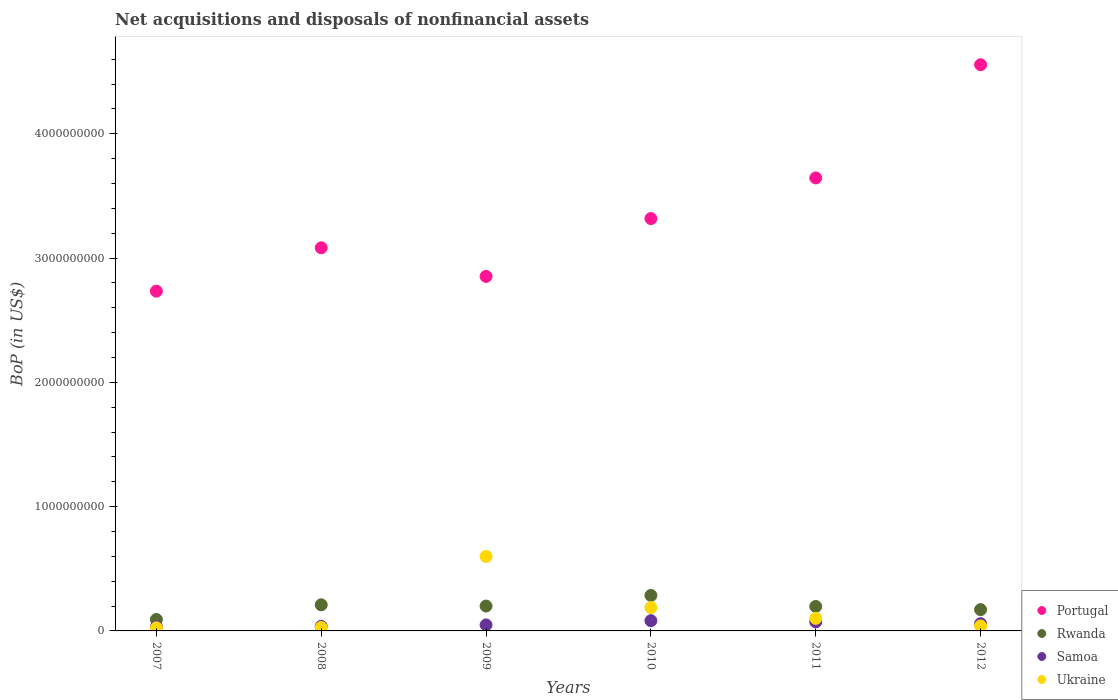What is the Balance of Payments in Portugal in 2008?
Give a very brief answer. 3.08e+09. Across all years, what is the maximum Balance of Payments in Samoa?
Ensure brevity in your answer.  8.24e+07. Across all years, what is the minimum Balance of Payments in Rwanda?
Keep it short and to the point. 9.20e+07. In which year was the Balance of Payments in Samoa maximum?
Your answer should be compact. 2010. What is the total Balance of Payments in Ukraine in the graph?
Provide a succinct answer. 9.81e+08. What is the difference between the Balance of Payments in Samoa in 2007 and that in 2012?
Offer a very short reply. -2.51e+07. What is the difference between the Balance of Payments in Rwanda in 2011 and the Balance of Payments in Ukraine in 2010?
Offer a terse response. 8.66e+06. What is the average Balance of Payments in Ukraine per year?
Ensure brevity in your answer.  1.64e+08. In the year 2007, what is the difference between the Balance of Payments in Rwanda and Balance of Payments in Portugal?
Your answer should be compact. -2.64e+09. In how many years, is the Balance of Payments in Samoa greater than 3200000000 US$?
Offer a very short reply. 0. What is the ratio of the Balance of Payments in Rwanda in 2007 to that in 2009?
Give a very brief answer. 0.46. Is the difference between the Balance of Payments in Rwanda in 2009 and 2010 greater than the difference between the Balance of Payments in Portugal in 2009 and 2010?
Make the answer very short. Yes. What is the difference between the highest and the second highest Balance of Payments in Ukraine?
Ensure brevity in your answer.  4.11e+08. What is the difference between the highest and the lowest Balance of Payments in Rwanda?
Make the answer very short. 1.94e+08. In how many years, is the Balance of Payments in Ukraine greater than the average Balance of Payments in Ukraine taken over all years?
Your answer should be compact. 2. Does the Balance of Payments in Ukraine monotonically increase over the years?
Offer a terse response. No. How many years are there in the graph?
Your answer should be compact. 6. Does the graph contain any zero values?
Offer a very short reply. No. How are the legend labels stacked?
Ensure brevity in your answer.  Vertical. What is the title of the graph?
Your response must be concise. Net acquisitions and disposals of nonfinancial assets. Does "Ghana" appear as one of the legend labels in the graph?
Offer a very short reply. No. What is the label or title of the X-axis?
Your response must be concise. Years. What is the label or title of the Y-axis?
Your answer should be compact. BoP (in US$). What is the BoP (in US$) in Portugal in 2007?
Offer a terse response. 2.73e+09. What is the BoP (in US$) of Rwanda in 2007?
Make the answer very short. 9.20e+07. What is the BoP (in US$) of Samoa in 2007?
Provide a short and direct response. 3.34e+07. What is the BoP (in US$) of Ukraine in 2007?
Provide a short and direct response. 2.50e+07. What is the BoP (in US$) in Portugal in 2008?
Your response must be concise. 3.08e+09. What is the BoP (in US$) of Rwanda in 2008?
Offer a terse response. 2.10e+08. What is the BoP (in US$) of Samoa in 2008?
Your answer should be very brief. 3.72e+07. What is the BoP (in US$) of Ukraine in 2008?
Provide a succinct answer. 2.80e+07. What is the BoP (in US$) of Portugal in 2009?
Give a very brief answer. 2.85e+09. What is the BoP (in US$) in Samoa in 2009?
Make the answer very short. 4.83e+07. What is the BoP (in US$) of Ukraine in 2009?
Offer a very short reply. 5.99e+08. What is the BoP (in US$) of Portugal in 2010?
Offer a terse response. 3.32e+09. What is the BoP (in US$) of Rwanda in 2010?
Make the answer very short. 2.86e+08. What is the BoP (in US$) in Samoa in 2010?
Your answer should be very brief. 8.24e+07. What is the BoP (in US$) of Ukraine in 2010?
Offer a terse response. 1.88e+08. What is the BoP (in US$) of Portugal in 2011?
Provide a short and direct response. 3.64e+09. What is the BoP (in US$) of Rwanda in 2011?
Make the answer very short. 1.97e+08. What is the BoP (in US$) of Samoa in 2011?
Offer a very short reply. 7.27e+07. What is the BoP (in US$) in Ukraine in 2011?
Ensure brevity in your answer.  1.01e+08. What is the BoP (in US$) of Portugal in 2012?
Your answer should be compact. 4.56e+09. What is the BoP (in US$) in Rwanda in 2012?
Give a very brief answer. 1.71e+08. What is the BoP (in US$) in Samoa in 2012?
Give a very brief answer. 5.84e+07. What is the BoP (in US$) of Ukraine in 2012?
Ensure brevity in your answer.  4.00e+07. Across all years, what is the maximum BoP (in US$) in Portugal?
Keep it short and to the point. 4.56e+09. Across all years, what is the maximum BoP (in US$) in Rwanda?
Ensure brevity in your answer.  2.86e+08. Across all years, what is the maximum BoP (in US$) in Samoa?
Your response must be concise. 8.24e+07. Across all years, what is the maximum BoP (in US$) in Ukraine?
Provide a short and direct response. 5.99e+08. Across all years, what is the minimum BoP (in US$) in Portugal?
Your answer should be very brief. 2.73e+09. Across all years, what is the minimum BoP (in US$) of Rwanda?
Keep it short and to the point. 9.20e+07. Across all years, what is the minimum BoP (in US$) in Samoa?
Give a very brief answer. 3.34e+07. Across all years, what is the minimum BoP (in US$) in Ukraine?
Your answer should be very brief. 2.50e+07. What is the total BoP (in US$) in Portugal in the graph?
Offer a terse response. 2.02e+1. What is the total BoP (in US$) of Rwanda in the graph?
Provide a short and direct response. 1.16e+09. What is the total BoP (in US$) of Samoa in the graph?
Your answer should be very brief. 3.32e+08. What is the total BoP (in US$) of Ukraine in the graph?
Give a very brief answer. 9.81e+08. What is the difference between the BoP (in US$) of Portugal in 2007 and that in 2008?
Make the answer very short. -3.49e+08. What is the difference between the BoP (in US$) of Rwanda in 2007 and that in 2008?
Your answer should be compact. -1.18e+08. What is the difference between the BoP (in US$) of Samoa in 2007 and that in 2008?
Make the answer very short. -3.81e+06. What is the difference between the BoP (in US$) in Portugal in 2007 and that in 2009?
Provide a succinct answer. -1.19e+08. What is the difference between the BoP (in US$) of Rwanda in 2007 and that in 2009?
Your response must be concise. -1.08e+08. What is the difference between the BoP (in US$) in Samoa in 2007 and that in 2009?
Give a very brief answer. -1.49e+07. What is the difference between the BoP (in US$) in Ukraine in 2007 and that in 2009?
Provide a short and direct response. -5.74e+08. What is the difference between the BoP (in US$) in Portugal in 2007 and that in 2010?
Your answer should be compact. -5.84e+08. What is the difference between the BoP (in US$) of Rwanda in 2007 and that in 2010?
Your response must be concise. -1.94e+08. What is the difference between the BoP (in US$) in Samoa in 2007 and that in 2010?
Offer a terse response. -4.90e+07. What is the difference between the BoP (in US$) of Ukraine in 2007 and that in 2010?
Provide a succinct answer. -1.63e+08. What is the difference between the BoP (in US$) in Portugal in 2007 and that in 2011?
Offer a very short reply. -9.11e+08. What is the difference between the BoP (in US$) in Rwanda in 2007 and that in 2011?
Provide a succinct answer. -1.05e+08. What is the difference between the BoP (in US$) of Samoa in 2007 and that in 2011?
Provide a succinct answer. -3.93e+07. What is the difference between the BoP (in US$) in Ukraine in 2007 and that in 2011?
Keep it short and to the point. -7.60e+07. What is the difference between the BoP (in US$) of Portugal in 2007 and that in 2012?
Offer a terse response. -1.82e+09. What is the difference between the BoP (in US$) of Rwanda in 2007 and that in 2012?
Offer a terse response. -7.92e+07. What is the difference between the BoP (in US$) of Samoa in 2007 and that in 2012?
Provide a short and direct response. -2.51e+07. What is the difference between the BoP (in US$) of Ukraine in 2007 and that in 2012?
Make the answer very short. -1.50e+07. What is the difference between the BoP (in US$) of Portugal in 2008 and that in 2009?
Keep it short and to the point. 2.30e+08. What is the difference between the BoP (in US$) in Rwanda in 2008 and that in 2009?
Your answer should be compact. 1.01e+07. What is the difference between the BoP (in US$) in Samoa in 2008 and that in 2009?
Keep it short and to the point. -1.11e+07. What is the difference between the BoP (in US$) of Ukraine in 2008 and that in 2009?
Ensure brevity in your answer.  -5.71e+08. What is the difference between the BoP (in US$) in Portugal in 2008 and that in 2010?
Provide a succinct answer. -2.35e+08. What is the difference between the BoP (in US$) in Rwanda in 2008 and that in 2010?
Keep it short and to the point. -7.56e+07. What is the difference between the BoP (in US$) of Samoa in 2008 and that in 2010?
Provide a short and direct response. -4.52e+07. What is the difference between the BoP (in US$) of Ukraine in 2008 and that in 2010?
Ensure brevity in your answer.  -1.60e+08. What is the difference between the BoP (in US$) of Portugal in 2008 and that in 2011?
Offer a terse response. -5.62e+08. What is the difference between the BoP (in US$) of Rwanda in 2008 and that in 2011?
Your answer should be compact. 1.34e+07. What is the difference between the BoP (in US$) in Samoa in 2008 and that in 2011?
Give a very brief answer. -3.55e+07. What is the difference between the BoP (in US$) in Ukraine in 2008 and that in 2011?
Provide a succinct answer. -7.30e+07. What is the difference between the BoP (in US$) of Portugal in 2008 and that in 2012?
Offer a terse response. -1.47e+09. What is the difference between the BoP (in US$) of Rwanda in 2008 and that in 2012?
Your answer should be compact. 3.88e+07. What is the difference between the BoP (in US$) of Samoa in 2008 and that in 2012?
Make the answer very short. -2.13e+07. What is the difference between the BoP (in US$) in Ukraine in 2008 and that in 2012?
Make the answer very short. -1.20e+07. What is the difference between the BoP (in US$) in Portugal in 2009 and that in 2010?
Your answer should be compact. -4.66e+08. What is the difference between the BoP (in US$) of Rwanda in 2009 and that in 2010?
Your response must be concise. -8.56e+07. What is the difference between the BoP (in US$) in Samoa in 2009 and that in 2010?
Provide a succinct answer. -3.41e+07. What is the difference between the BoP (in US$) of Ukraine in 2009 and that in 2010?
Keep it short and to the point. 4.11e+08. What is the difference between the BoP (in US$) in Portugal in 2009 and that in 2011?
Your answer should be very brief. -7.92e+08. What is the difference between the BoP (in US$) in Rwanda in 2009 and that in 2011?
Give a very brief answer. 3.34e+06. What is the difference between the BoP (in US$) in Samoa in 2009 and that in 2011?
Provide a short and direct response. -2.44e+07. What is the difference between the BoP (in US$) of Ukraine in 2009 and that in 2011?
Your response must be concise. 4.98e+08. What is the difference between the BoP (in US$) of Portugal in 2009 and that in 2012?
Provide a short and direct response. -1.70e+09. What is the difference between the BoP (in US$) of Rwanda in 2009 and that in 2012?
Provide a short and direct response. 2.88e+07. What is the difference between the BoP (in US$) of Samoa in 2009 and that in 2012?
Make the answer very short. -1.01e+07. What is the difference between the BoP (in US$) in Ukraine in 2009 and that in 2012?
Your answer should be very brief. 5.59e+08. What is the difference between the BoP (in US$) in Portugal in 2010 and that in 2011?
Keep it short and to the point. -3.27e+08. What is the difference between the BoP (in US$) in Rwanda in 2010 and that in 2011?
Ensure brevity in your answer.  8.90e+07. What is the difference between the BoP (in US$) in Samoa in 2010 and that in 2011?
Ensure brevity in your answer.  9.68e+06. What is the difference between the BoP (in US$) in Ukraine in 2010 and that in 2011?
Provide a short and direct response. 8.70e+07. What is the difference between the BoP (in US$) in Portugal in 2010 and that in 2012?
Make the answer very short. -1.24e+09. What is the difference between the BoP (in US$) in Rwanda in 2010 and that in 2012?
Provide a short and direct response. 1.14e+08. What is the difference between the BoP (in US$) of Samoa in 2010 and that in 2012?
Offer a terse response. 2.39e+07. What is the difference between the BoP (in US$) of Ukraine in 2010 and that in 2012?
Your answer should be very brief. 1.48e+08. What is the difference between the BoP (in US$) of Portugal in 2011 and that in 2012?
Your answer should be compact. -9.11e+08. What is the difference between the BoP (in US$) in Rwanda in 2011 and that in 2012?
Your answer should be compact. 2.54e+07. What is the difference between the BoP (in US$) of Samoa in 2011 and that in 2012?
Your answer should be compact. 1.42e+07. What is the difference between the BoP (in US$) of Ukraine in 2011 and that in 2012?
Make the answer very short. 6.10e+07. What is the difference between the BoP (in US$) of Portugal in 2007 and the BoP (in US$) of Rwanda in 2008?
Keep it short and to the point. 2.52e+09. What is the difference between the BoP (in US$) of Portugal in 2007 and the BoP (in US$) of Samoa in 2008?
Provide a short and direct response. 2.70e+09. What is the difference between the BoP (in US$) of Portugal in 2007 and the BoP (in US$) of Ukraine in 2008?
Give a very brief answer. 2.71e+09. What is the difference between the BoP (in US$) of Rwanda in 2007 and the BoP (in US$) of Samoa in 2008?
Make the answer very short. 5.48e+07. What is the difference between the BoP (in US$) in Rwanda in 2007 and the BoP (in US$) in Ukraine in 2008?
Ensure brevity in your answer.  6.40e+07. What is the difference between the BoP (in US$) of Samoa in 2007 and the BoP (in US$) of Ukraine in 2008?
Ensure brevity in your answer.  5.38e+06. What is the difference between the BoP (in US$) in Portugal in 2007 and the BoP (in US$) in Rwanda in 2009?
Provide a short and direct response. 2.53e+09. What is the difference between the BoP (in US$) in Portugal in 2007 and the BoP (in US$) in Samoa in 2009?
Make the answer very short. 2.69e+09. What is the difference between the BoP (in US$) in Portugal in 2007 and the BoP (in US$) in Ukraine in 2009?
Provide a short and direct response. 2.13e+09. What is the difference between the BoP (in US$) of Rwanda in 2007 and the BoP (in US$) of Samoa in 2009?
Give a very brief answer. 4.37e+07. What is the difference between the BoP (in US$) in Rwanda in 2007 and the BoP (in US$) in Ukraine in 2009?
Keep it short and to the point. -5.07e+08. What is the difference between the BoP (in US$) of Samoa in 2007 and the BoP (in US$) of Ukraine in 2009?
Offer a very short reply. -5.66e+08. What is the difference between the BoP (in US$) in Portugal in 2007 and the BoP (in US$) in Rwanda in 2010?
Make the answer very short. 2.45e+09. What is the difference between the BoP (in US$) in Portugal in 2007 and the BoP (in US$) in Samoa in 2010?
Make the answer very short. 2.65e+09. What is the difference between the BoP (in US$) in Portugal in 2007 and the BoP (in US$) in Ukraine in 2010?
Give a very brief answer. 2.55e+09. What is the difference between the BoP (in US$) in Rwanda in 2007 and the BoP (in US$) in Samoa in 2010?
Provide a succinct answer. 9.66e+06. What is the difference between the BoP (in US$) of Rwanda in 2007 and the BoP (in US$) of Ukraine in 2010?
Keep it short and to the point. -9.60e+07. What is the difference between the BoP (in US$) of Samoa in 2007 and the BoP (in US$) of Ukraine in 2010?
Ensure brevity in your answer.  -1.55e+08. What is the difference between the BoP (in US$) of Portugal in 2007 and the BoP (in US$) of Rwanda in 2011?
Your answer should be compact. 2.54e+09. What is the difference between the BoP (in US$) in Portugal in 2007 and the BoP (in US$) in Samoa in 2011?
Ensure brevity in your answer.  2.66e+09. What is the difference between the BoP (in US$) in Portugal in 2007 and the BoP (in US$) in Ukraine in 2011?
Offer a very short reply. 2.63e+09. What is the difference between the BoP (in US$) of Rwanda in 2007 and the BoP (in US$) of Samoa in 2011?
Provide a short and direct response. 1.93e+07. What is the difference between the BoP (in US$) of Rwanda in 2007 and the BoP (in US$) of Ukraine in 2011?
Keep it short and to the point. -8.96e+06. What is the difference between the BoP (in US$) of Samoa in 2007 and the BoP (in US$) of Ukraine in 2011?
Your response must be concise. -6.76e+07. What is the difference between the BoP (in US$) in Portugal in 2007 and the BoP (in US$) in Rwanda in 2012?
Your response must be concise. 2.56e+09. What is the difference between the BoP (in US$) of Portugal in 2007 and the BoP (in US$) of Samoa in 2012?
Offer a terse response. 2.68e+09. What is the difference between the BoP (in US$) of Portugal in 2007 and the BoP (in US$) of Ukraine in 2012?
Your response must be concise. 2.69e+09. What is the difference between the BoP (in US$) of Rwanda in 2007 and the BoP (in US$) of Samoa in 2012?
Provide a short and direct response. 3.36e+07. What is the difference between the BoP (in US$) in Rwanda in 2007 and the BoP (in US$) in Ukraine in 2012?
Offer a terse response. 5.20e+07. What is the difference between the BoP (in US$) in Samoa in 2007 and the BoP (in US$) in Ukraine in 2012?
Provide a succinct answer. -6.62e+06. What is the difference between the BoP (in US$) in Portugal in 2008 and the BoP (in US$) in Rwanda in 2009?
Your answer should be compact. 2.88e+09. What is the difference between the BoP (in US$) of Portugal in 2008 and the BoP (in US$) of Samoa in 2009?
Your answer should be very brief. 3.03e+09. What is the difference between the BoP (in US$) in Portugal in 2008 and the BoP (in US$) in Ukraine in 2009?
Your answer should be compact. 2.48e+09. What is the difference between the BoP (in US$) in Rwanda in 2008 and the BoP (in US$) in Samoa in 2009?
Make the answer very short. 1.62e+08. What is the difference between the BoP (in US$) in Rwanda in 2008 and the BoP (in US$) in Ukraine in 2009?
Your response must be concise. -3.89e+08. What is the difference between the BoP (in US$) in Samoa in 2008 and the BoP (in US$) in Ukraine in 2009?
Offer a very short reply. -5.62e+08. What is the difference between the BoP (in US$) of Portugal in 2008 and the BoP (in US$) of Rwanda in 2010?
Your answer should be very brief. 2.80e+09. What is the difference between the BoP (in US$) of Portugal in 2008 and the BoP (in US$) of Samoa in 2010?
Ensure brevity in your answer.  3.00e+09. What is the difference between the BoP (in US$) in Portugal in 2008 and the BoP (in US$) in Ukraine in 2010?
Ensure brevity in your answer.  2.89e+09. What is the difference between the BoP (in US$) in Rwanda in 2008 and the BoP (in US$) in Samoa in 2010?
Your answer should be compact. 1.28e+08. What is the difference between the BoP (in US$) in Rwanda in 2008 and the BoP (in US$) in Ukraine in 2010?
Your response must be concise. 2.21e+07. What is the difference between the BoP (in US$) in Samoa in 2008 and the BoP (in US$) in Ukraine in 2010?
Your answer should be very brief. -1.51e+08. What is the difference between the BoP (in US$) in Portugal in 2008 and the BoP (in US$) in Rwanda in 2011?
Provide a short and direct response. 2.89e+09. What is the difference between the BoP (in US$) of Portugal in 2008 and the BoP (in US$) of Samoa in 2011?
Give a very brief answer. 3.01e+09. What is the difference between the BoP (in US$) of Portugal in 2008 and the BoP (in US$) of Ukraine in 2011?
Your answer should be very brief. 2.98e+09. What is the difference between the BoP (in US$) of Rwanda in 2008 and the BoP (in US$) of Samoa in 2011?
Ensure brevity in your answer.  1.37e+08. What is the difference between the BoP (in US$) in Rwanda in 2008 and the BoP (in US$) in Ukraine in 2011?
Your response must be concise. 1.09e+08. What is the difference between the BoP (in US$) in Samoa in 2008 and the BoP (in US$) in Ukraine in 2011?
Provide a succinct answer. -6.38e+07. What is the difference between the BoP (in US$) in Portugal in 2008 and the BoP (in US$) in Rwanda in 2012?
Your answer should be very brief. 2.91e+09. What is the difference between the BoP (in US$) in Portugal in 2008 and the BoP (in US$) in Samoa in 2012?
Keep it short and to the point. 3.02e+09. What is the difference between the BoP (in US$) in Portugal in 2008 and the BoP (in US$) in Ukraine in 2012?
Your answer should be very brief. 3.04e+09. What is the difference between the BoP (in US$) of Rwanda in 2008 and the BoP (in US$) of Samoa in 2012?
Ensure brevity in your answer.  1.52e+08. What is the difference between the BoP (in US$) in Rwanda in 2008 and the BoP (in US$) in Ukraine in 2012?
Your answer should be very brief. 1.70e+08. What is the difference between the BoP (in US$) of Samoa in 2008 and the BoP (in US$) of Ukraine in 2012?
Make the answer very short. -2.81e+06. What is the difference between the BoP (in US$) in Portugal in 2009 and the BoP (in US$) in Rwanda in 2010?
Offer a very short reply. 2.57e+09. What is the difference between the BoP (in US$) in Portugal in 2009 and the BoP (in US$) in Samoa in 2010?
Keep it short and to the point. 2.77e+09. What is the difference between the BoP (in US$) in Portugal in 2009 and the BoP (in US$) in Ukraine in 2010?
Your answer should be compact. 2.66e+09. What is the difference between the BoP (in US$) of Rwanda in 2009 and the BoP (in US$) of Samoa in 2010?
Offer a very short reply. 1.18e+08. What is the difference between the BoP (in US$) of Rwanda in 2009 and the BoP (in US$) of Ukraine in 2010?
Your answer should be compact. 1.20e+07. What is the difference between the BoP (in US$) in Samoa in 2009 and the BoP (in US$) in Ukraine in 2010?
Offer a very short reply. -1.40e+08. What is the difference between the BoP (in US$) of Portugal in 2009 and the BoP (in US$) of Rwanda in 2011?
Ensure brevity in your answer.  2.66e+09. What is the difference between the BoP (in US$) in Portugal in 2009 and the BoP (in US$) in Samoa in 2011?
Provide a short and direct response. 2.78e+09. What is the difference between the BoP (in US$) in Portugal in 2009 and the BoP (in US$) in Ukraine in 2011?
Provide a succinct answer. 2.75e+09. What is the difference between the BoP (in US$) in Rwanda in 2009 and the BoP (in US$) in Samoa in 2011?
Make the answer very short. 1.27e+08. What is the difference between the BoP (in US$) of Rwanda in 2009 and the BoP (in US$) of Ukraine in 2011?
Offer a terse response. 9.90e+07. What is the difference between the BoP (in US$) of Samoa in 2009 and the BoP (in US$) of Ukraine in 2011?
Offer a very short reply. -5.27e+07. What is the difference between the BoP (in US$) in Portugal in 2009 and the BoP (in US$) in Rwanda in 2012?
Your answer should be compact. 2.68e+09. What is the difference between the BoP (in US$) of Portugal in 2009 and the BoP (in US$) of Samoa in 2012?
Provide a succinct answer. 2.79e+09. What is the difference between the BoP (in US$) in Portugal in 2009 and the BoP (in US$) in Ukraine in 2012?
Keep it short and to the point. 2.81e+09. What is the difference between the BoP (in US$) in Rwanda in 2009 and the BoP (in US$) in Samoa in 2012?
Your response must be concise. 1.42e+08. What is the difference between the BoP (in US$) in Rwanda in 2009 and the BoP (in US$) in Ukraine in 2012?
Ensure brevity in your answer.  1.60e+08. What is the difference between the BoP (in US$) in Samoa in 2009 and the BoP (in US$) in Ukraine in 2012?
Your answer should be very brief. 8.31e+06. What is the difference between the BoP (in US$) of Portugal in 2010 and the BoP (in US$) of Rwanda in 2011?
Offer a very short reply. 3.12e+09. What is the difference between the BoP (in US$) in Portugal in 2010 and the BoP (in US$) in Samoa in 2011?
Give a very brief answer. 3.25e+09. What is the difference between the BoP (in US$) in Portugal in 2010 and the BoP (in US$) in Ukraine in 2011?
Keep it short and to the point. 3.22e+09. What is the difference between the BoP (in US$) in Rwanda in 2010 and the BoP (in US$) in Samoa in 2011?
Provide a succinct answer. 2.13e+08. What is the difference between the BoP (in US$) in Rwanda in 2010 and the BoP (in US$) in Ukraine in 2011?
Keep it short and to the point. 1.85e+08. What is the difference between the BoP (in US$) of Samoa in 2010 and the BoP (in US$) of Ukraine in 2011?
Offer a very short reply. -1.86e+07. What is the difference between the BoP (in US$) in Portugal in 2010 and the BoP (in US$) in Rwanda in 2012?
Your answer should be very brief. 3.15e+09. What is the difference between the BoP (in US$) in Portugal in 2010 and the BoP (in US$) in Samoa in 2012?
Offer a very short reply. 3.26e+09. What is the difference between the BoP (in US$) of Portugal in 2010 and the BoP (in US$) of Ukraine in 2012?
Give a very brief answer. 3.28e+09. What is the difference between the BoP (in US$) of Rwanda in 2010 and the BoP (in US$) of Samoa in 2012?
Offer a terse response. 2.27e+08. What is the difference between the BoP (in US$) of Rwanda in 2010 and the BoP (in US$) of Ukraine in 2012?
Make the answer very short. 2.46e+08. What is the difference between the BoP (in US$) of Samoa in 2010 and the BoP (in US$) of Ukraine in 2012?
Your response must be concise. 4.24e+07. What is the difference between the BoP (in US$) of Portugal in 2011 and the BoP (in US$) of Rwanda in 2012?
Make the answer very short. 3.47e+09. What is the difference between the BoP (in US$) of Portugal in 2011 and the BoP (in US$) of Samoa in 2012?
Keep it short and to the point. 3.59e+09. What is the difference between the BoP (in US$) in Portugal in 2011 and the BoP (in US$) in Ukraine in 2012?
Give a very brief answer. 3.60e+09. What is the difference between the BoP (in US$) in Rwanda in 2011 and the BoP (in US$) in Samoa in 2012?
Ensure brevity in your answer.  1.38e+08. What is the difference between the BoP (in US$) in Rwanda in 2011 and the BoP (in US$) in Ukraine in 2012?
Provide a short and direct response. 1.57e+08. What is the difference between the BoP (in US$) of Samoa in 2011 and the BoP (in US$) of Ukraine in 2012?
Your answer should be very brief. 3.27e+07. What is the average BoP (in US$) in Portugal per year?
Provide a succinct answer. 3.36e+09. What is the average BoP (in US$) in Rwanda per year?
Provide a short and direct response. 1.93e+08. What is the average BoP (in US$) of Samoa per year?
Offer a very short reply. 5.54e+07. What is the average BoP (in US$) in Ukraine per year?
Provide a short and direct response. 1.64e+08. In the year 2007, what is the difference between the BoP (in US$) of Portugal and BoP (in US$) of Rwanda?
Provide a short and direct response. 2.64e+09. In the year 2007, what is the difference between the BoP (in US$) of Portugal and BoP (in US$) of Samoa?
Give a very brief answer. 2.70e+09. In the year 2007, what is the difference between the BoP (in US$) in Portugal and BoP (in US$) in Ukraine?
Your answer should be compact. 2.71e+09. In the year 2007, what is the difference between the BoP (in US$) in Rwanda and BoP (in US$) in Samoa?
Offer a terse response. 5.87e+07. In the year 2007, what is the difference between the BoP (in US$) in Rwanda and BoP (in US$) in Ukraine?
Offer a terse response. 6.70e+07. In the year 2007, what is the difference between the BoP (in US$) of Samoa and BoP (in US$) of Ukraine?
Give a very brief answer. 8.38e+06. In the year 2008, what is the difference between the BoP (in US$) of Portugal and BoP (in US$) of Rwanda?
Keep it short and to the point. 2.87e+09. In the year 2008, what is the difference between the BoP (in US$) in Portugal and BoP (in US$) in Samoa?
Your answer should be compact. 3.05e+09. In the year 2008, what is the difference between the BoP (in US$) in Portugal and BoP (in US$) in Ukraine?
Provide a short and direct response. 3.05e+09. In the year 2008, what is the difference between the BoP (in US$) in Rwanda and BoP (in US$) in Samoa?
Give a very brief answer. 1.73e+08. In the year 2008, what is the difference between the BoP (in US$) in Rwanda and BoP (in US$) in Ukraine?
Offer a terse response. 1.82e+08. In the year 2008, what is the difference between the BoP (in US$) in Samoa and BoP (in US$) in Ukraine?
Your response must be concise. 9.19e+06. In the year 2009, what is the difference between the BoP (in US$) of Portugal and BoP (in US$) of Rwanda?
Your answer should be very brief. 2.65e+09. In the year 2009, what is the difference between the BoP (in US$) in Portugal and BoP (in US$) in Samoa?
Offer a very short reply. 2.80e+09. In the year 2009, what is the difference between the BoP (in US$) of Portugal and BoP (in US$) of Ukraine?
Ensure brevity in your answer.  2.25e+09. In the year 2009, what is the difference between the BoP (in US$) of Rwanda and BoP (in US$) of Samoa?
Make the answer very short. 1.52e+08. In the year 2009, what is the difference between the BoP (in US$) in Rwanda and BoP (in US$) in Ukraine?
Your answer should be very brief. -3.99e+08. In the year 2009, what is the difference between the BoP (in US$) of Samoa and BoP (in US$) of Ukraine?
Give a very brief answer. -5.51e+08. In the year 2010, what is the difference between the BoP (in US$) of Portugal and BoP (in US$) of Rwanda?
Provide a short and direct response. 3.03e+09. In the year 2010, what is the difference between the BoP (in US$) of Portugal and BoP (in US$) of Samoa?
Give a very brief answer. 3.24e+09. In the year 2010, what is the difference between the BoP (in US$) in Portugal and BoP (in US$) in Ukraine?
Offer a very short reply. 3.13e+09. In the year 2010, what is the difference between the BoP (in US$) of Rwanda and BoP (in US$) of Samoa?
Provide a short and direct response. 2.03e+08. In the year 2010, what is the difference between the BoP (in US$) in Rwanda and BoP (in US$) in Ukraine?
Offer a very short reply. 9.76e+07. In the year 2010, what is the difference between the BoP (in US$) in Samoa and BoP (in US$) in Ukraine?
Give a very brief answer. -1.06e+08. In the year 2011, what is the difference between the BoP (in US$) of Portugal and BoP (in US$) of Rwanda?
Provide a short and direct response. 3.45e+09. In the year 2011, what is the difference between the BoP (in US$) in Portugal and BoP (in US$) in Samoa?
Keep it short and to the point. 3.57e+09. In the year 2011, what is the difference between the BoP (in US$) of Portugal and BoP (in US$) of Ukraine?
Offer a terse response. 3.54e+09. In the year 2011, what is the difference between the BoP (in US$) of Rwanda and BoP (in US$) of Samoa?
Give a very brief answer. 1.24e+08. In the year 2011, what is the difference between the BoP (in US$) of Rwanda and BoP (in US$) of Ukraine?
Offer a terse response. 9.57e+07. In the year 2011, what is the difference between the BoP (in US$) of Samoa and BoP (in US$) of Ukraine?
Provide a short and direct response. -2.83e+07. In the year 2012, what is the difference between the BoP (in US$) of Portugal and BoP (in US$) of Rwanda?
Your response must be concise. 4.38e+09. In the year 2012, what is the difference between the BoP (in US$) in Portugal and BoP (in US$) in Samoa?
Your answer should be very brief. 4.50e+09. In the year 2012, what is the difference between the BoP (in US$) of Portugal and BoP (in US$) of Ukraine?
Keep it short and to the point. 4.52e+09. In the year 2012, what is the difference between the BoP (in US$) in Rwanda and BoP (in US$) in Samoa?
Provide a succinct answer. 1.13e+08. In the year 2012, what is the difference between the BoP (in US$) in Rwanda and BoP (in US$) in Ukraine?
Provide a short and direct response. 1.31e+08. In the year 2012, what is the difference between the BoP (in US$) of Samoa and BoP (in US$) of Ukraine?
Ensure brevity in your answer.  1.84e+07. What is the ratio of the BoP (in US$) in Portugal in 2007 to that in 2008?
Ensure brevity in your answer.  0.89. What is the ratio of the BoP (in US$) in Rwanda in 2007 to that in 2008?
Give a very brief answer. 0.44. What is the ratio of the BoP (in US$) of Samoa in 2007 to that in 2008?
Provide a succinct answer. 0.9. What is the ratio of the BoP (in US$) of Ukraine in 2007 to that in 2008?
Give a very brief answer. 0.89. What is the ratio of the BoP (in US$) in Portugal in 2007 to that in 2009?
Ensure brevity in your answer.  0.96. What is the ratio of the BoP (in US$) in Rwanda in 2007 to that in 2009?
Offer a terse response. 0.46. What is the ratio of the BoP (in US$) of Samoa in 2007 to that in 2009?
Your answer should be very brief. 0.69. What is the ratio of the BoP (in US$) in Ukraine in 2007 to that in 2009?
Provide a succinct answer. 0.04. What is the ratio of the BoP (in US$) in Portugal in 2007 to that in 2010?
Offer a terse response. 0.82. What is the ratio of the BoP (in US$) in Rwanda in 2007 to that in 2010?
Give a very brief answer. 0.32. What is the ratio of the BoP (in US$) of Samoa in 2007 to that in 2010?
Provide a succinct answer. 0.41. What is the ratio of the BoP (in US$) in Ukraine in 2007 to that in 2010?
Offer a terse response. 0.13. What is the ratio of the BoP (in US$) in Portugal in 2007 to that in 2011?
Make the answer very short. 0.75. What is the ratio of the BoP (in US$) in Rwanda in 2007 to that in 2011?
Offer a very short reply. 0.47. What is the ratio of the BoP (in US$) in Samoa in 2007 to that in 2011?
Ensure brevity in your answer.  0.46. What is the ratio of the BoP (in US$) in Ukraine in 2007 to that in 2011?
Provide a short and direct response. 0.25. What is the ratio of the BoP (in US$) in Portugal in 2007 to that in 2012?
Offer a very short reply. 0.6. What is the ratio of the BoP (in US$) in Rwanda in 2007 to that in 2012?
Ensure brevity in your answer.  0.54. What is the ratio of the BoP (in US$) of Samoa in 2007 to that in 2012?
Ensure brevity in your answer.  0.57. What is the ratio of the BoP (in US$) of Ukraine in 2007 to that in 2012?
Your answer should be very brief. 0.62. What is the ratio of the BoP (in US$) of Portugal in 2008 to that in 2009?
Give a very brief answer. 1.08. What is the ratio of the BoP (in US$) of Rwanda in 2008 to that in 2009?
Offer a very short reply. 1.05. What is the ratio of the BoP (in US$) of Samoa in 2008 to that in 2009?
Offer a very short reply. 0.77. What is the ratio of the BoP (in US$) in Ukraine in 2008 to that in 2009?
Keep it short and to the point. 0.05. What is the ratio of the BoP (in US$) of Portugal in 2008 to that in 2010?
Offer a terse response. 0.93. What is the ratio of the BoP (in US$) in Rwanda in 2008 to that in 2010?
Provide a short and direct response. 0.74. What is the ratio of the BoP (in US$) of Samoa in 2008 to that in 2010?
Offer a terse response. 0.45. What is the ratio of the BoP (in US$) in Ukraine in 2008 to that in 2010?
Ensure brevity in your answer.  0.15. What is the ratio of the BoP (in US$) of Portugal in 2008 to that in 2011?
Your answer should be compact. 0.85. What is the ratio of the BoP (in US$) of Rwanda in 2008 to that in 2011?
Make the answer very short. 1.07. What is the ratio of the BoP (in US$) in Samoa in 2008 to that in 2011?
Your answer should be compact. 0.51. What is the ratio of the BoP (in US$) in Ukraine in 2008 to that in 2011?
Offer a terse response. 0.28. What is the ratio of the BoP (in US$) of Portugal in 2008 to that in 2012?
Your answer should be compact. 0.68. What is the ratio of the BoP (in US$) of Rwanda in 2008 to that in 2012?
Offer a very short reply. 1.23. What is the ratio of the BoP (in US$) of Samoa in 2008 to that in 2012?
Make the answer very short. 0.64. What is the ratio of the BoP (in US$) in Ukraine in 2008 to that in 2012?
Make the answer very short. 0.7. What is the ratio of the BoP (in US$) in Portugal in 2009 to that in 2010?
Give a very brief answer. 0.86. What is the ratio of the BoP (in US$) of Rwanda in 2009 to that in 2010?
Give a very brief answer. 0.7. What is the ratio of the BoP (in US$) of Samoa in 2009 to that in 2010?
Your answer should be very brief. 0.59. What is the ratio of the BoP (in US$) of Ukraine in 2009 to that in 2010?
Your answer should be compact. 3.19. What is the ratio of the BoP (in US$) of Portugal in 2009 to that in 2011?
Provide a short and direct response. 0.78. What is the ratio of the BoP (in US$) of Rwanda in 2009 to that in 2011?
Your response must be concise. 1.02. What is the ratio of the BoP (in US$) of Samoa in 2009 to that in 2011?
Offer a terse response. 0.66. What is the ratio of the BoP (in US$) in Ukraine in 2009 to that in 2011?
Your response must be concise. 5.93. What is the ratio of the BoP (in US$) of Portugal in 2009 to that in 2012?
Offer a very short reply. 0.63. What is the ratio of the BoP (in US$) in Rwanda in 2009 to that in 2012?
Offer a terse response. 1.17. What is the ratio of the BoP (in US$) of Samoa in 2009 to that in 2012?
Ensure brevity in your answer.  0.83. What is the ratio of the BoP (in US$) in Ukraine in 2009 to that in 2012?
Keep it short and to the point. 14.97. What is the ratio of the BoP (in US$) in Portugal in 2010 to that in 2011?
Offer a terse response. 0.91. What is the ratio of the BoP (in US$) of Rwanda in 2010 to that in 2011?
Provide a short and direct response. 1.45. What is the ratio of the BoP (in US$) of Samoa in 2010 to that in 2011?
Provide a short and direct response. 1.13. What is the ratio of the BoP (in US$) of Ukraine in 2010 to that in 2011?
Ensure brevity in your answer.  1.86. What is the ratio of the BoP (in US$) of Portugal in 2010 to that in 2012?
Provide a succinct answer. 0.73. What is the ratio of the BoP (in US$) of Rwanda in 2010 to that in 2012?
Keep it short and to the point. 1.67. What is the ratio of the BoP (in US$) of Samoa in 2010 to that in 2012?
Ensure brevity in your answer.  1.41. What is the ratio of the BoP (in US$) of Ukraine in 2010 to that in 2012?
Your response must be concise. 4.7. What is the ratio of the BoP (in US$) in Rwanda in 2011 to that in 2012?
Provide a succinct answer. 1.15. What is the ratio of the BoP (in US$) in Samoa in 2011 to that in 2012?
Provide a succinct answer. 1.24. What is the ratio of the BoP (in US$) of Ukraine in 2011 to that in 2012?
Your response must be concise. 2.52. What is the difference between the highest and the second highest BoP (in US$) of Portugal?
Give a very brief answer. 9.11e+08. What is the difference between the highest and the second highest BoP (in US$) in Rwanda?
Your answer should be compact. 7.56e+07. What is the difference between the highest and the second highest BoP (in US$) in Samoa?
Offer a terse response. 9.68e+06. What is the difference between the highest and the second highest BoP (in US$) in Ukraine?
Make the answer very short. 4.11e+08. What is the difference between the highest and the lowest BoP (in US$) of Portugal?
Your response must be concise. 1.82e+09. What is the difference between the highest and the lowest BoP (in US$) of Rwanda?
Give a very brief answer. 1.94e+08. What is the difference between the highest and the lowest BoP (in US$) of Samoa?
Make the answer very short. 4.90e+07. What is the difference between the highest and the lowest BoP (in US$) of Ukraine?
Your response must be concise. 5.74e+08. 